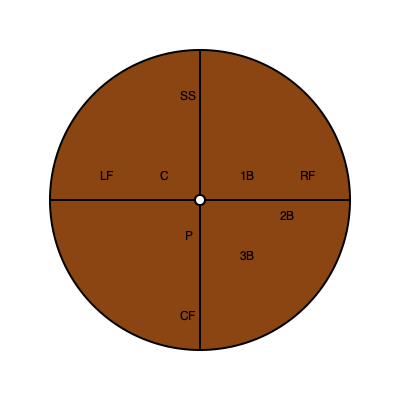Based on the baseball diamond diagram, which infield position is typically responsible for covering the most ground and requires the highest level of agility? To answer this question, we need to analyze the positions of infielders on the baseball diamond:

1. First Base (1B): Covers the area near first base.
2. Second Base (2B): Covers the area between first and second base.
3. Third Base (3B): Covers the area near third base.
4. Shortstop (SS): Covers the area between second and third base.

Among these positions:

1. The shortstop (SS) is positioned in the largest gap between bases.
2. SS needs to cover ground towards both second and third base.
3. SS often needs to make plays in shallow left field and behind second base.
4. SS is responsible for relay throws from the outfield to home plate.
5. SS frequently needs to make difficult plays on ground balls hit to either side.

The shortstop's position requires them to cover more ground than other infielders and demands a high level of agility to make quick movements and difficult plays.
Answer: Shortstop (SS) 